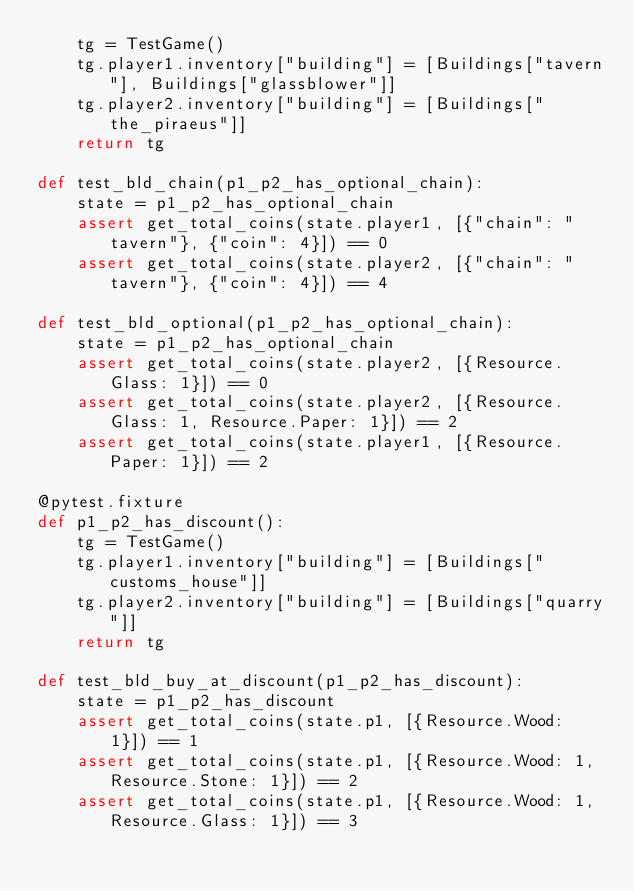<code> <loc_0><loc_0><loc_500><loc_500><_Python_>    tg = TestGame()
    tg.player1.inventory["building"] = [Buildings["tavern"], Buildings["glassblower"]]
    tg.player2.inventory["building"] = [Buildings["the_piraeus"]]
    return tg

def test_bld_chain(p1_p2_has_optional_chain):
    state = p1_p2_has_optional_chain
    assert get_total_coins(state.player1, [{"chain": "tavern"}, {"coin": 4}]) == 0
    assert get_total_coins(state.player2, [{"chain": "tavern"}, {"coin": 4}]) == 4

def test_bld_optional(p1_p2_has_optional_chain):
    state = p1_p2_has_optional_chain
    assert get_total_coins(state.player2, [{Resource.Glass: 1}]) == 0
    assert get_total_coins(state.player2, [{Resource.Glass: 1, Resource.Paper: 1}]) == 2
    assert get_total_coins(state.player1, [{Resource.Paper: 1}]) == 2

@pytest.fixture
def p1_p2_has_discount():
    tg = TestGame()
    tg.player1.inventory["building"] = [Buildings["customs_house"]]
    tg.player2.inventory["building"] = [Buildings["quarry"]]
    return tg

def test_bld_buy_at_discount(p1_p2_has_discount):
    state = p1_p2_has_discount
    assert get_total_coins(state.p1, [{Resource.Wood: 1}]) == 1
    assert get_total_coins(state.p1, [{Resource.Wood: 1, Resource.Stone: 1}]) == 2
    assert get_total_coins(state.p1, [{Resource.Wood: 1, Resource.Glass: 1}]) == 3
</code> 